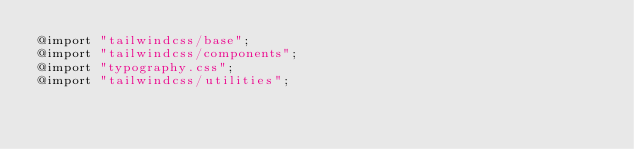Convert code to text. <code><loc_0><loc_0><loc_500><loc_500><_CSS_>@import "tailwindcss/base";
@import "tailwindcss/components";
@import "typography.css";
@import "tailwindcss/utilities";
</code> 